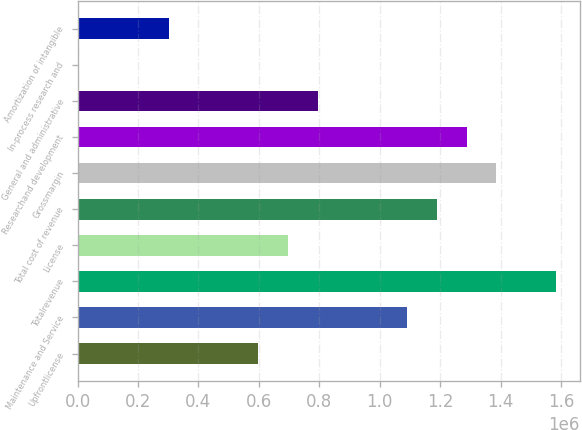Convert chart to OTSL. <chart><loc_0><loc_0><loc_500><loc_500><bar_chart><fcel>Upfrontlicense<fcel>Maintenance and Service<fcel>Totalrevenue<fcel>License<fcel>Total cost of revenue<fcel>Grossmargin<fcel>Researchand development<fcel>General and administrative<fcel>In-process research and<fcel>Amortization of intangible<nl><fcel>597439<fcel>1.09055e+06<fcel>1.58367e+06<fcel>696062<fcel>1.18918e+06<fcel>1.38642e+06<fcel>1.2878e+06<fcel>794685<fcel>5700<fcel>301569<nl></chart> 